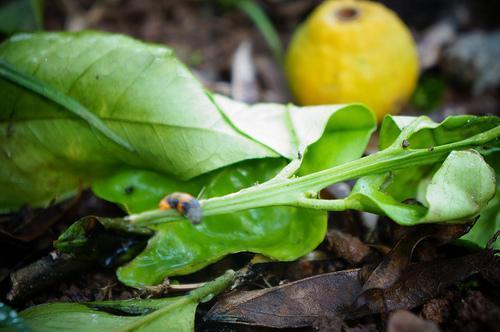How many bugs are in the picture?
Give a very brief answer. 1. 